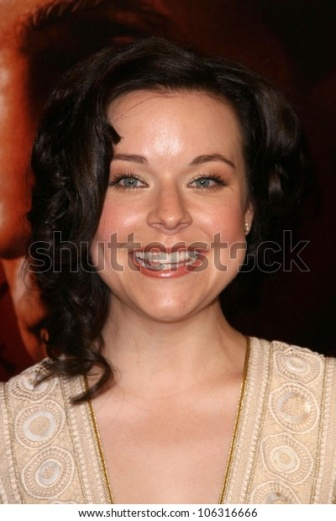Describe the fashion style in this image. The fashion style in this image is elegant and classic. The woman is wearing a beige dress with a distinctive circular pattern. The dress appears to have a vintage-inspired design, combining detail and subtlety. Her accessories are minimal but tasteful, including delicate earrings that complement her look. The overall style exudes sophistication and timeless elegance. What do the patterns on her dress signify? The circular patterns on her dress add a unique and artistic element to her outfit. These patterns could be indicative of a designer focus on texture and visual interest, suggesting a blend of traditional and contemporary fashion. The intricate design signifies a level of detailed craftsmanship, making the dress not only visually appealing but also a statement of style and elegance. Imagine a scenario where the patterns on her dress come alive. What would happen? In an imaginative scenario where the circular patterns on her dress come alive, they might transform into swirling, dynamic shapes that move gracefully across the fabric. These moving patterns could create a mesmerizing effect, mesmerizing onlookers as they shift and change colors in response to the woman's movements. The living patterns could tell a story or depict beautiful scenes, making her dress a captivating display of living art. 